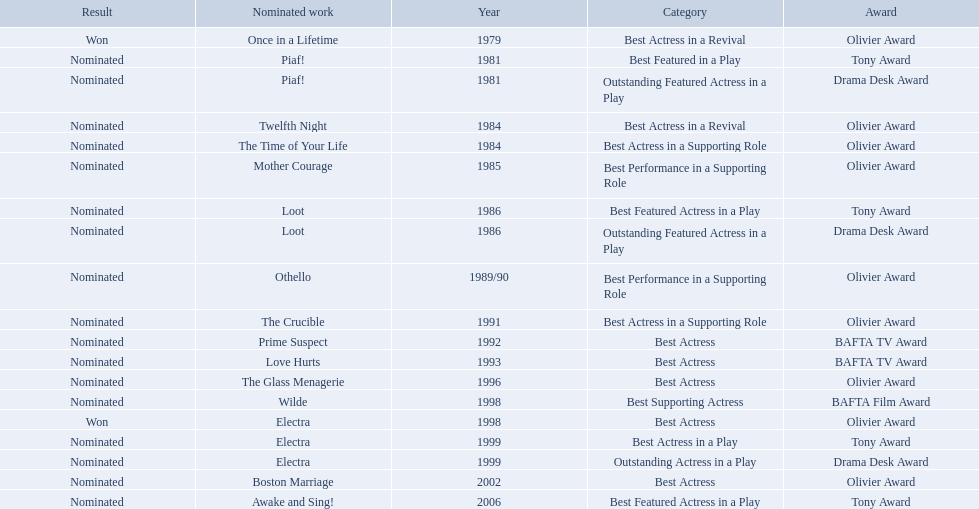What play was wanamaker nominated outstanding featured actress in a play? Piaf!. What year was wanamaker in once in a lifetime play? 1979. What play in 1984 was wanamaker nominated best actress? Twelfth Night. 